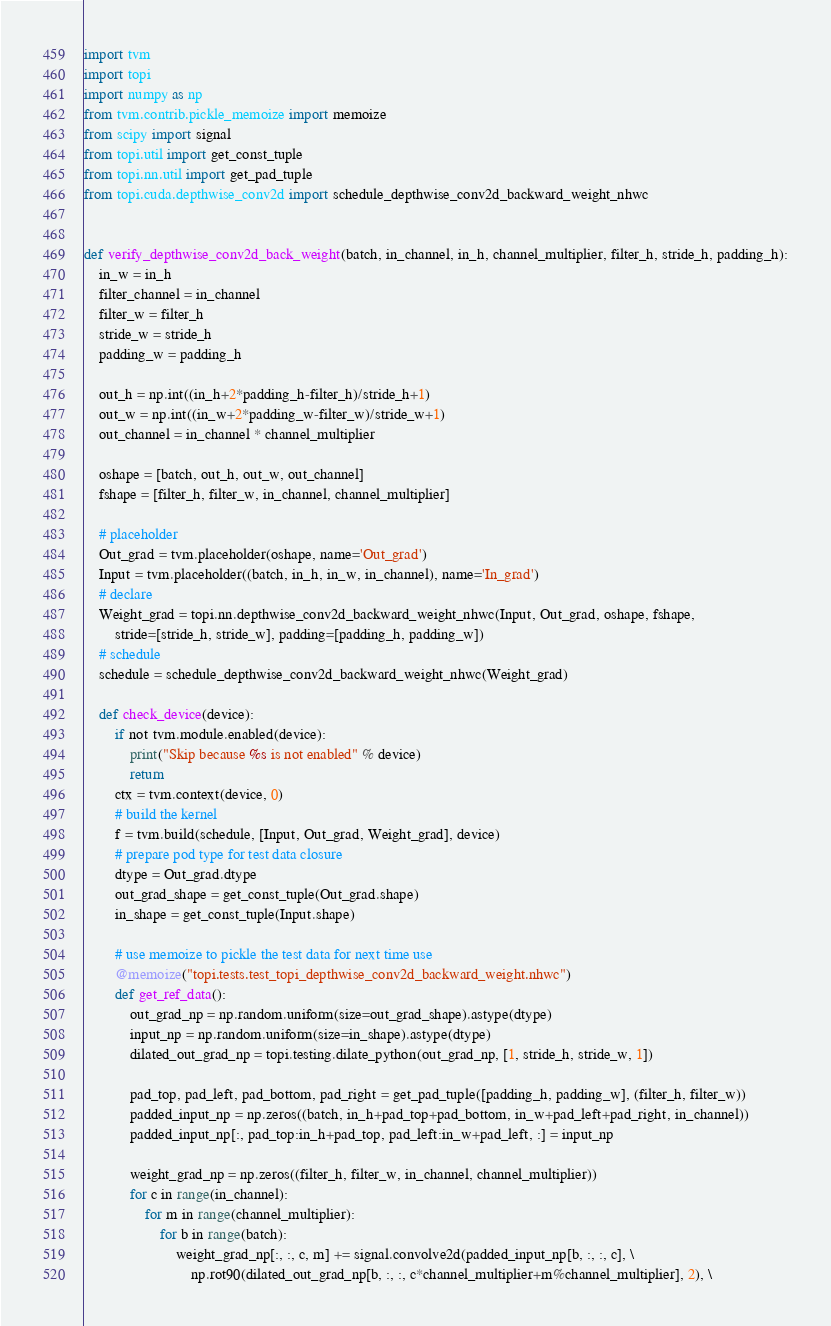<code> <loc_0><loc_0><loc_500><loc_500><_Python_>import tvm
import topi
import numpy as np
from tvm.contrib.pickle_memoize import memoize
from scipy import signal
from topi.util import get_const_tuple
from topi.nn.util import get_pad_tuple
from topi.cuda.depthwise_conv2d import schedule_depthwise_conv2d_backward_weight_nhwc


def verify_depthwise_conv2d_back_weight(batch, in_channel, in_h, channel_multiplier, filter_h, stride_h, padding_h):
    in_w = in_h
    filter_channel = in_channel
    filter_w = filter_h
    stride_w = stride_h
    padding_w = padding_h

    out_h = np.int((in_h+2*padding_h-filter_h)/stride_h+1)
    out_w = np.int((in_w+2*padding_w-filter_w)/stride_w+1)
    out_channel = in_channel * channel_multiplier

    oshape = [batch, out_h, out_w, out_channel]
    fshape = [filter_h, filter_w, in_channel, channel_multiplier]

    # placeholder
    Out_grad = tvm.placeholder(oshape, name='Out_grad')
    Input = tvm.placeholder((batch, in_h, in_w, in_channel), name='In_grad')
    # declare
    Weight_grad = topi.nn.depthwise_conv2d_backward_weight_nhwc(Input, Out_grad, oshape, fshape,
        stride=[stride_h, stride_w], padding=[padding_h, padding_w])
    # schedule
    schedule = schedule_depthwise_conv2d_backward_weight_nhwc(Weight_grad)

    def check_device(device):
        if not tvm.module.enabled(device):
            print("Skip because %s is not enabled" % device)
            return
        ctx = tvm.context(device, 0)
        # build the kernel
        f = tvm.build(schedule, [Input, Out_grad, Weight_grad], device)
        # prepare pod type for test data closure
        dtype = Out_grad.dtype
        out_grad_shape = get_const_tuple(Out_grad.shape)
        in_shape = get_const_tuple(Input.shape)

        # use memoize to pickle the test data for next time use
        @memoize("topi.tests.test_topi_depthwise_conv2d_backward_weight.nhwc")
        def get_ref_data():
            out_grad_np = np.random.uniform(size=out_grad_shape).astype(dtype)
            input_np = np.random.uniform(size=in_shape).astype(dtype)
            dilated_out_grad_np = topi.testing.dilate_python(out_grad_np, [1, stride_h, stride_w, 1])

            pad_top, pad_left, pad_bottom, pad_right = get_pad_tuple([padding_h, padding_w], (filter_h, filter_w))
            padded_input_np = np.zeros((batch, in_h+pad_top+pad_bottom, in_w+pad_left+pad_right, in_channel))
            padded_input_np[:, pad_top:in_h+pad_top, pad_left:in_w+pad_left, :] = input_np

            weight_grad_np = np.zeros((filter_h, filter_w, in_channel, channel_multiplier))
            for c in range(in_channel):
                for m in range(channel_multiplier):
                    for b in range(batch):
                        weight_grad_np[:, :, c, m] += signal.convolve2d(padded_input_np[b, :, :, c], \
                            np.rot90(dilated_out_grad_np[b, :, :, c*channel_multiplier+m%channel_multiplier], 2), \</code> 